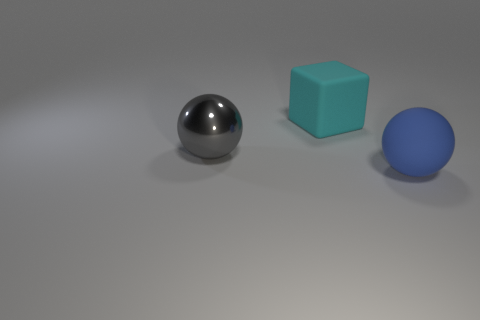What is the shape of the big thing that is both on the right side of the gray metal ball and in front of the cyan thing?
Keep it short and to the point. Sphere. Is there anything else that has the same size as the gray metal object?
Give a very brief answer. Yes. There is a sphere that is the same material as the large block; what is its size?
Offer a terse response. Large. What number of things are cyan things on the right side of the gray metallic thing or rubber objects that are in front of the cyan matte thing?
Give a very brief answer. 2. There is a object to the left of the cyan thing; does it have the same size as the large blue matte sphere?
Make the answer very short. Yes. What color is the sphere that is in front of the big gray ball?
Keep it short and to the point. Blue. There is another matte object that is the same shape as the gray thing; what is its color?
Offer a very short reply. Blue. How many large matte balls are right of the big object that is behind the sphere on the left side of the big cyan rubber block?
Ensure brevity in your answer.  1. Is there any other thing that has the same material as the big cyan object?
Provide a succinct answer. Yes. Is the number of big matte things that are left of the big cyan cube less than the number of balls?
Give a very brief answer. Yes. 